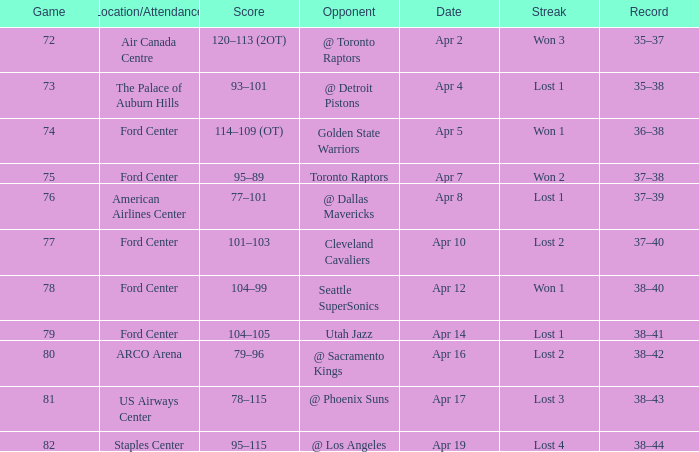Who was the opponent for game 75? Toronto Raptors. 